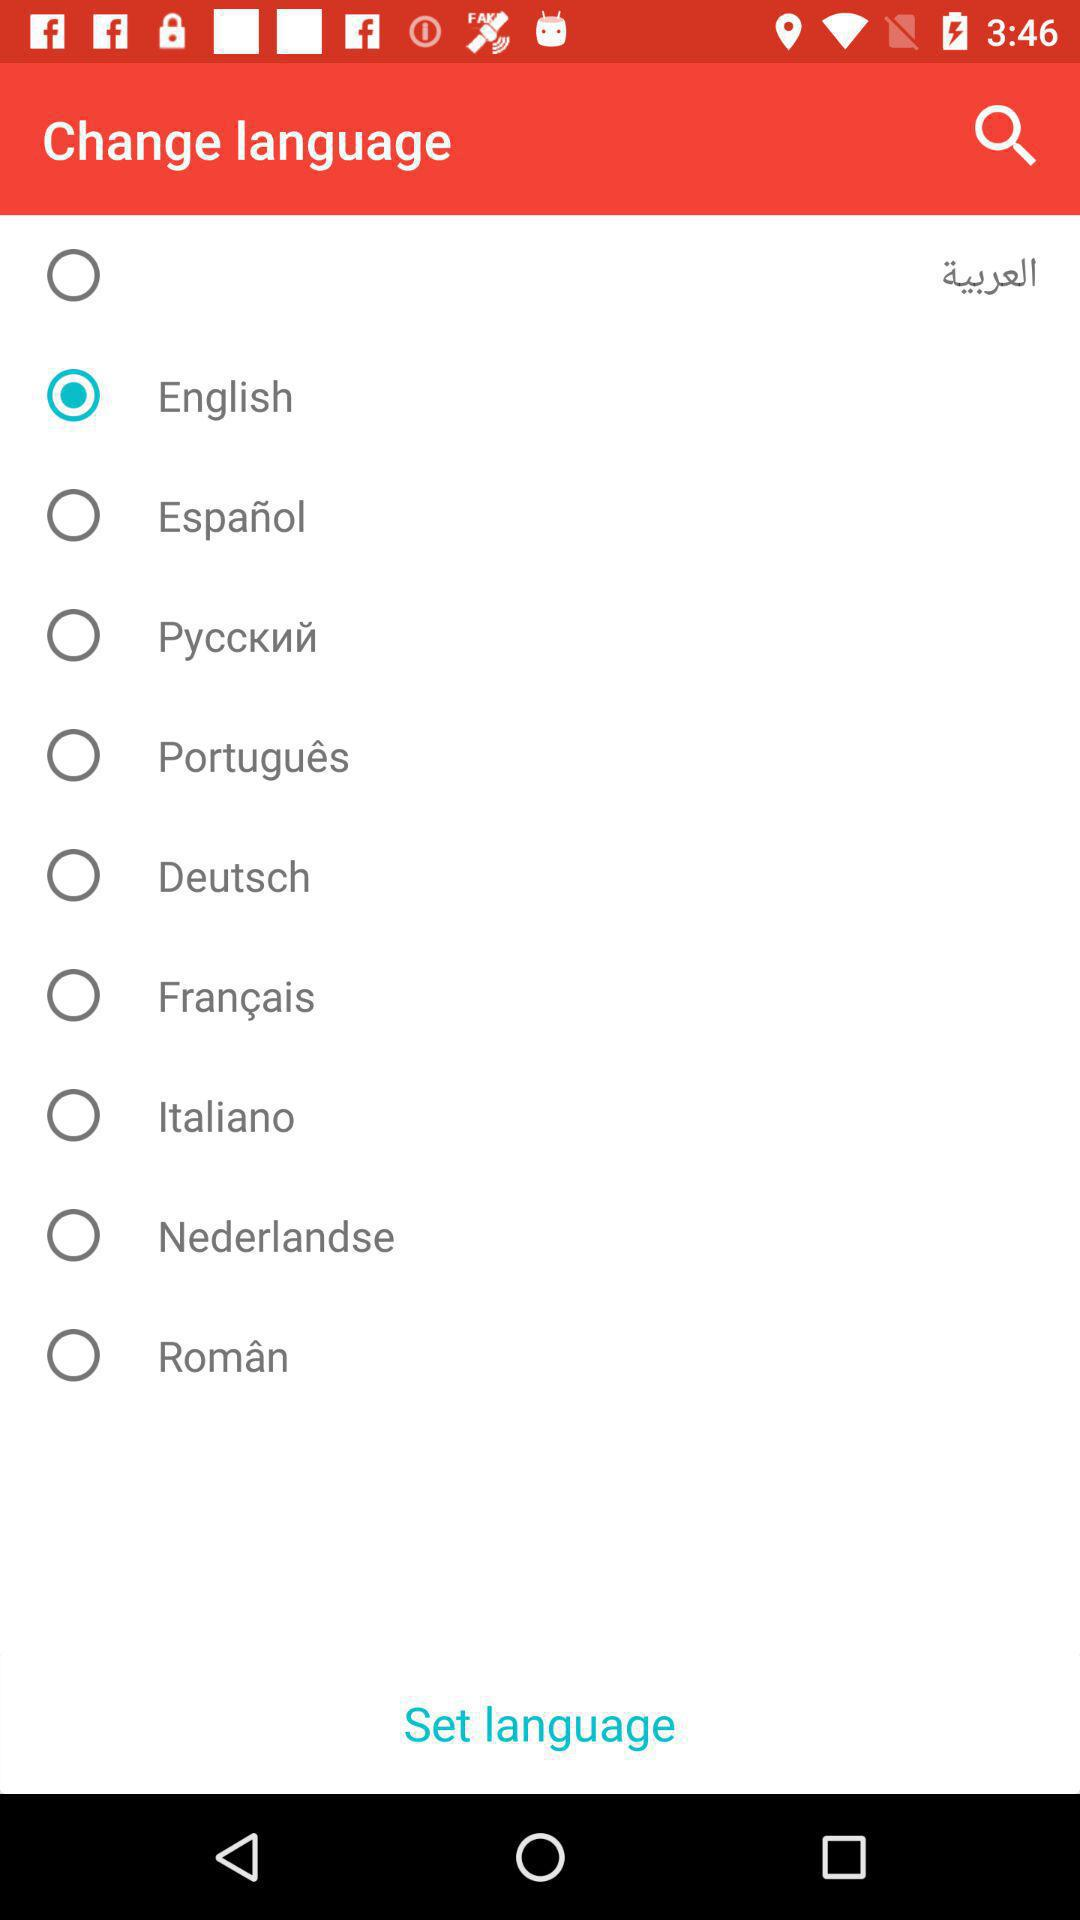Which option was selected? The selected option is "English". 